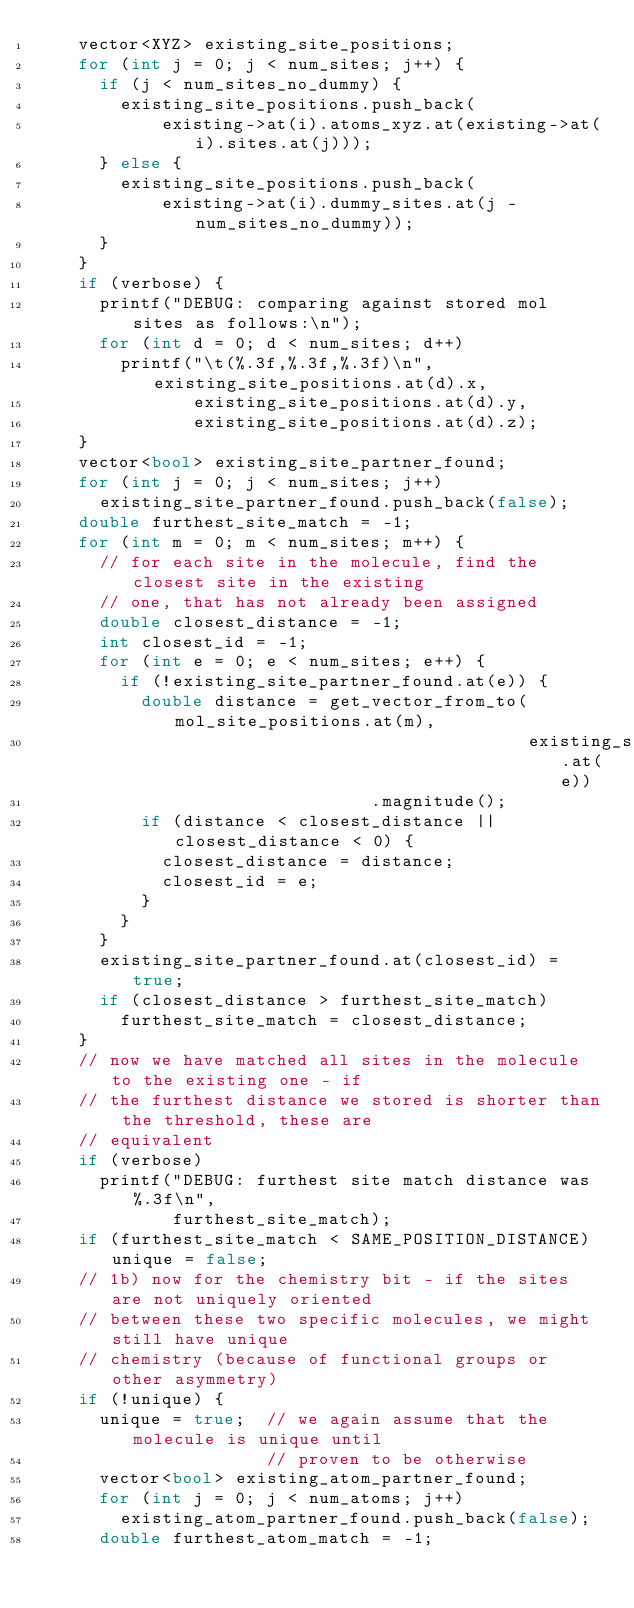<code> <loc_0><loc_0><loc_500><loc_500><_C++_>    vector<XYZ> existing_site_positions;
    for (int j = 0; j < num_sites; j++) {
      if (j < num_sites_no_dummy) {
        existing_site_positions.push_back(
            existing->at(i).atoms_xyz.at(existing->at(i).sites.at(j)));
      } else {
        existing_site_positions.push_back(
            existing->at(i).dummy_sites.at(j - num_sites_no_dummy));
      }
    }
    if (verbose) {
      printf("DEBUG: comparing against stored mol sites as follows:\n");
      for (int d = 0; d < num_sites; d++)
        printf("\t(%.3f,%.3f,%.3f)\n", existing_site_positions.at(d).x,
               existing_site_positions.at(d).y,
               existing_site_positions.at(d).z);
    }
    vector<bool> existing_site_partner_found;
    for (int j = 0; j < num_sites; j++)
      existing_site_partner_found.push_back(false);
    double furthest_site_match = -1;
    for (int m = 0; m < num_sites; m++) {
      // for each site in the molecule, find the closest site in the existing
      // one, that has not already been assigned
      double closest_distance = -1;
      int closest_id = -1;
      for (int e = 0; e < num_sites; e++) {
        if (!existing_site_partner_found.at(e)) {
          double distance = get_vector_from_to(mol_site_positions.at(m),
                                               existing_site_positions.at(e))
                                .magnitude();
          if (distance < closest_distance || closest_distance < 0) {
            closest_distance = distance;
            closest_id = e;
          }
        }
      }
      existing_site_partner_found.at(closest_id) = true;
      if (closest_distance > furthest_site_match)
        furthest_site_match = closest_distance;
    }
    // now we have matched all sites in the molecule to the existing one - if
    // the furthest distance we stored is shorter than the threshold, these are
    // equivalent
    if (verbose)
      printf("DEBUG: furthest site match distance was %.3f\n",
             furthest_site_match);
    if (furthest_site_match < SAME_POSITION_DISTANCE) unique = false;
    // 1b) now for the chemistry bit - if the sites are not uniquely oriented
    // between these two specific molecules, we might still have unique
    // chemistry (because of functional groups or other asymmetry)
    if (!unique) {
      unique = true;  // we again assume that the molecule is unique until
                      // proven to be otherwise
      vector<bool> existing_atom_partner_found;
      for (int j = 0; j < num_atoms; j++)
        existing_atom_partner_found.push_back(false);
      double furthest_atom_match = -1;</code> 